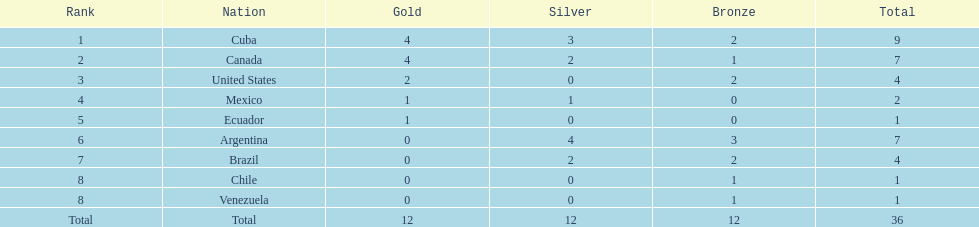Where does mexico rank? 4. 